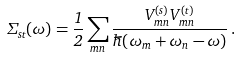Convert formula to latex. <formula><loc_0><loc_0><loc_500><loc_500>\Sigma _ { s t } ( \omega ) = \frac { 1 } { 2 } \sum _ { m n } \frac { V _ { m n } ^ { ( s ) } V _ { m n } ^ { ( t ) } } { \hbar { ( } \omega _ { m } + \omega _ { n } - \omega ) } \, .</formula> 